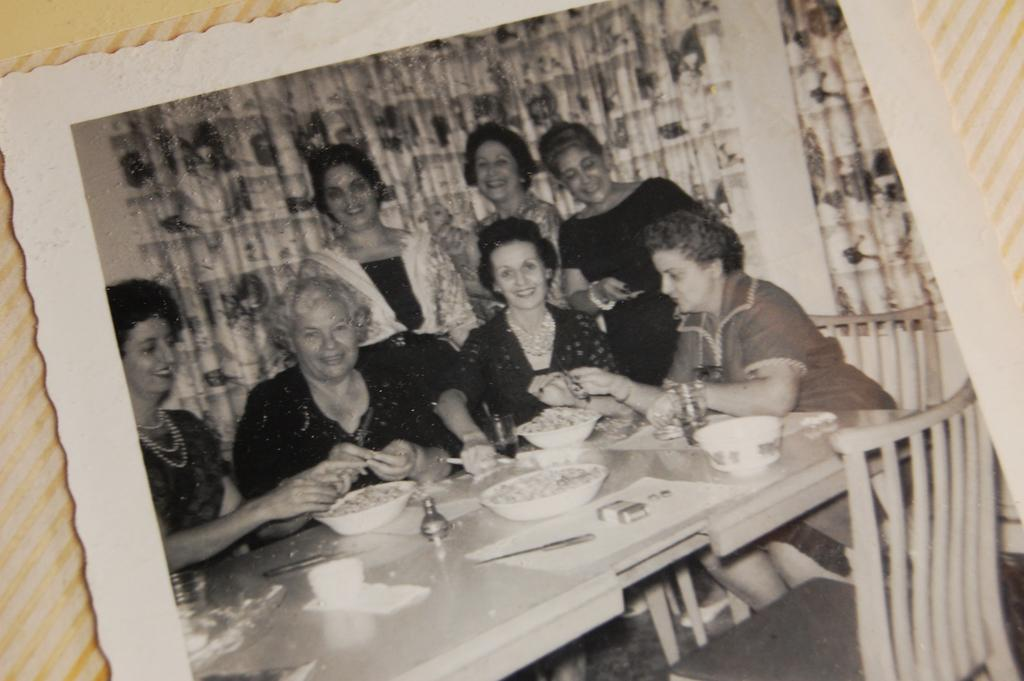How many women are sitting in the image? There are four women sitting on chairs in the image. What are the sitting women doing? The women are having food. Can you describe the women in the background? In the background, there are three women standing. What is the expression of the standing women? The standing women are smiling. What type of object is the image contained within? The image is a photo frame. Can you hear the sound of the ocean in the image? There is no sound in the image, and the ocean is not present. How many clocks can be seen in the image? There are no clocks visible in the image. 